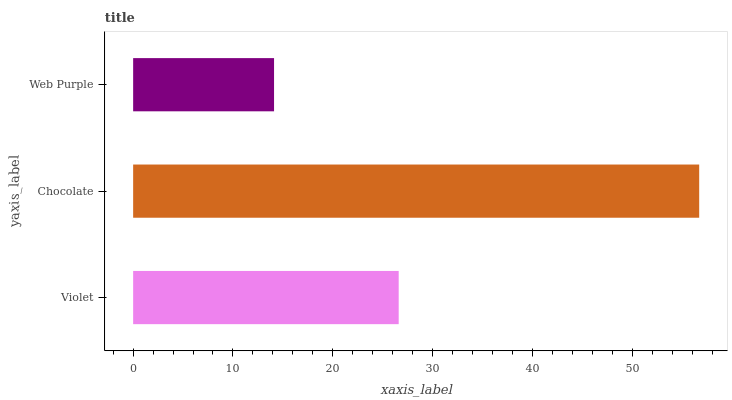Is Web Purple the minimum?
Answer yes or no. Yes. Is Chocolate the maximum?
Answer yes or no. Yes. Is Chocolate the minimum?
Answer yes or no. No. Is Web Purple the maximum?
Answer yes or no. No. Is Chocolate greater than Web Purple?
Answer yes or no. Yes. Is Web Purple less than Chocolate?
Answer yes or no. Yes. Is Web Purple greater than Chocolate?
Answer yes or no. No. Is Chocolate less than Web Purple?
Answer yes or no. No. Is Violet the high median?
Answer yes or no. Yes. Is Violet the low median?
Answer yes or no. Yes. Is Web Purple the high median?
Answer yes or no. No. Is Web Purple the low median?
Answer yes or no. No. 